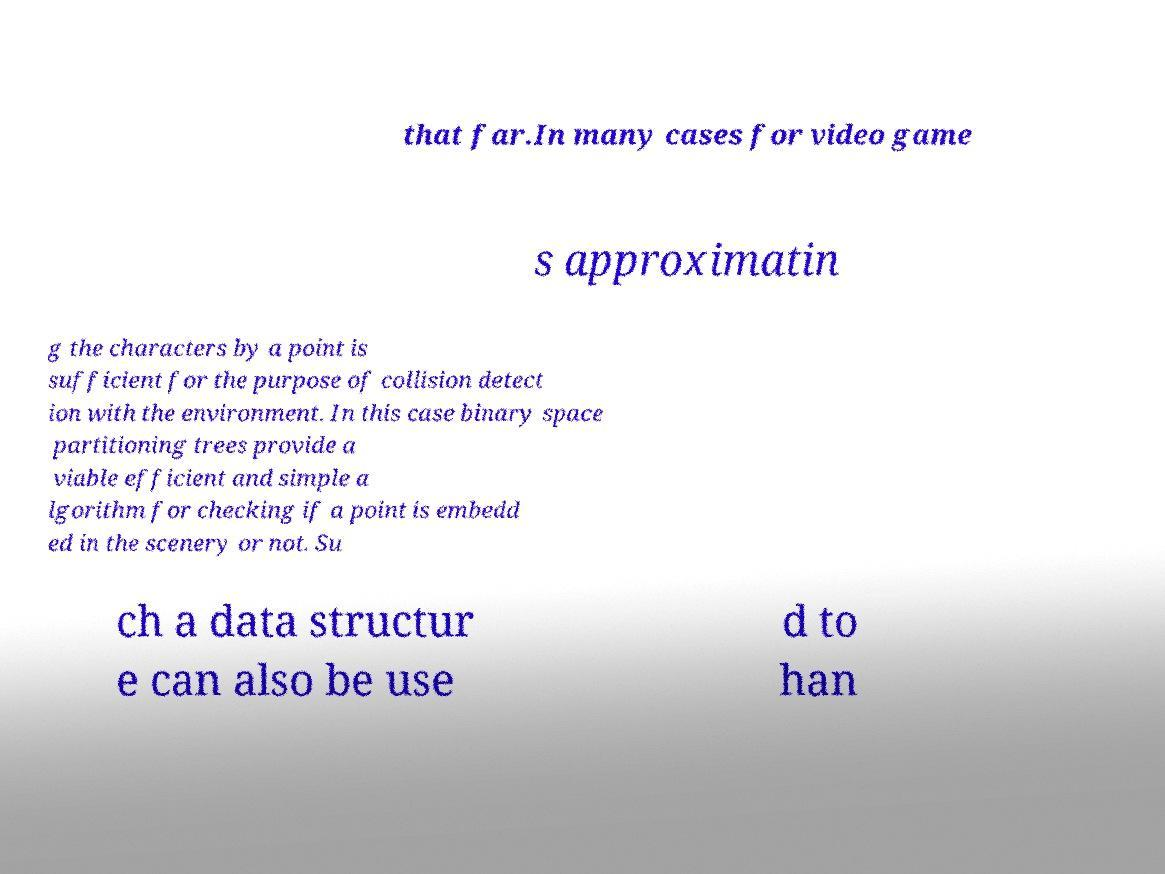I need the written content from this picture converted into text. Can you do that? that far.In many cases for video game s approximatin g the characters by a point is sufficient for the purpose of collision detect ion with the environment. In this case binary space partitioning trees provide a viable efficient and simple a lgorithm for checking if a point is embedd ed in the scenery or not. Su ch a data structur e can also be use d to han 